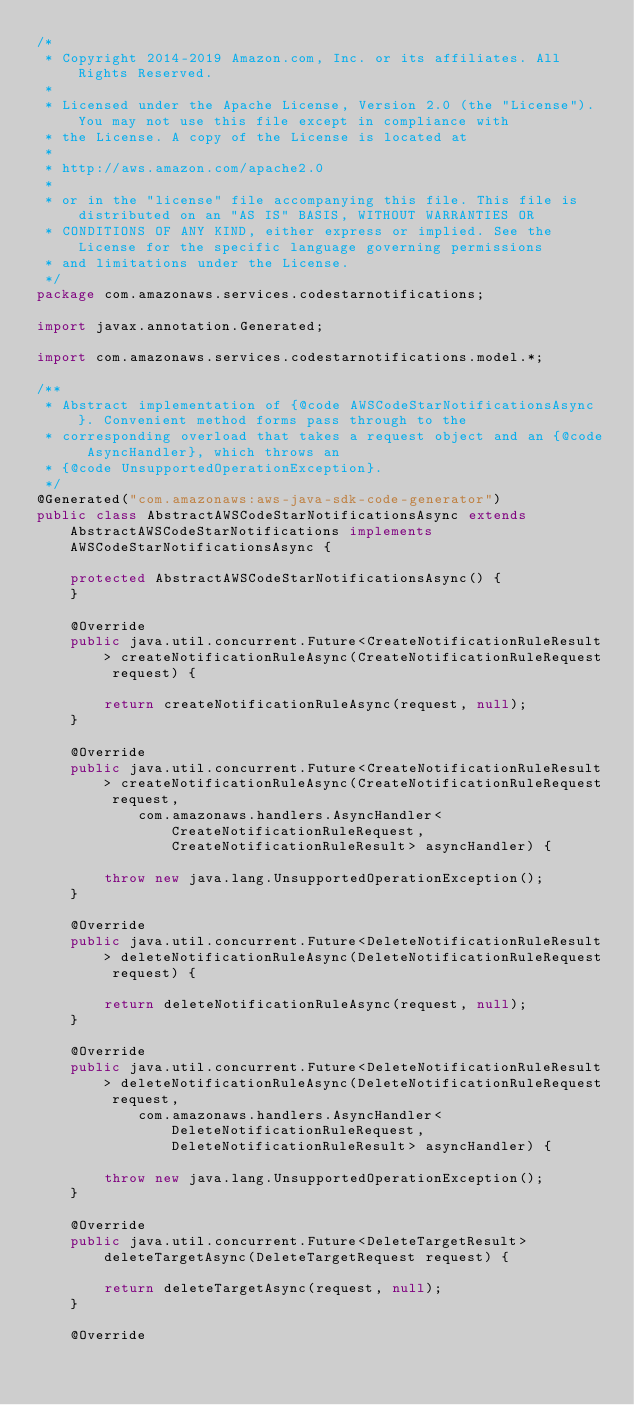Convert code to text. <code><loc_0><loc_0><loc_500><loc_500><_Java_>/*
 * Copyright 2014-2019 Amazon.com, Inc. or its affiliates. All Rights Reserved.
 * 
 * Licensed under the Apache License, Version 2.0 (the "License"). You may not use this file except in compliance with
 * the License. A copy of the License is located at
 * 
 * http://aws.amazon.com/apache2.0
 * 
 * or in the "license" file accompanying this file. This file is distributed on an "AS IS" BASIS, WITHOUT WARRANTIES OR
 * CONDITIONS OF ANY KIND, either express or implied. See the License for the specific language governing permissions
 * and limitations under the License.
 */
package com.amazonaws.services.codestarnotifications;

import javax.annotation.Generated;

import com.amazonaws.services.codestarnotifications.model.*;

/**
 * Abstract implementation of {@code AWSCodeStarNotificationsAsync}. Convenient method forms pass through to the
 * corresponding overload that takes a request object and an {@code AsyncHandler}, which throws an
 * {@code UnsupportedOperationException}.
 */
@Generated("com.amazonaws:aws-java-sdk-code-generator")
public class AbstractAWSCodeStarNotificationsAsync extends AbstractAWSCodeStarNotifications implements AWSCodeStarNotificationsAsync {

    protected AbstractAWSCodeStarNotificationsAsync() {
    }

    @Override
    public java.util.concurrent.Future<CreateNotificationRuleResult> createNotificationRuleAsync(CreateNotificationRuleRequest request) {

        return createNotificationRuleAsync(request, null);
    }

    @Override
    public java.util.concurrent.Future<CreateNotificationRuleResult> createNotificationRuleAsync(CreateNotificationRuleRequest request,
            com.amazonaws.handlers.AsyncHandler<CreateNotificationRuleRequest, CreateNotificationRuleResult> asyncHandler) {

        throw new java.lang.UnsupportedOperationException();
    }

    @Override
    public java.util.concurrent.Future<DeleteNotificationRuleResult> deleteNotificationRuleAsync(DeleteNotificationRuleRequest request) {

        return deleteNotificationRuleAsync(request, null);
    }

    @Override
    public java.util.concurrent.Future<DeleteNotificationRuleResult> deleteNotificationRuleAsync(DeleteNotificationRuleRequest request,
            com.amazonaws.handlers.AsyncHandler<DeleteNotificationRuleRequest, DeleteNotificationRuleResult> asyncHandler) {

        throw new java.lang.UnsupportedOperationException();
    }

    @Override
    public java.util.concurrent.Future<DeleteTargetResult> deleteTargetAsync(DeleteTargetRequest request) {

        return deleteTargetAsync(request, null);
    }

    @Override</code> 